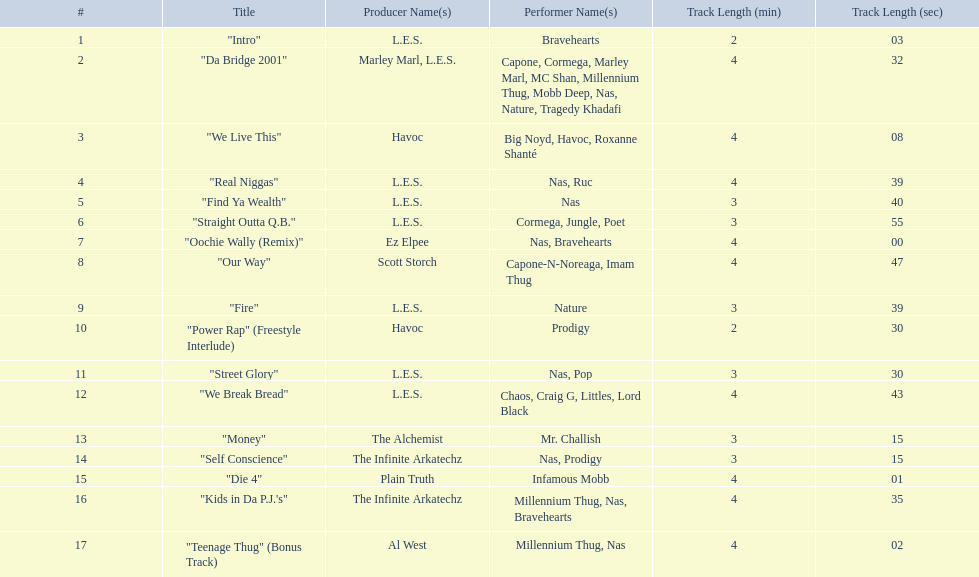What is the name of the last song on the album? "Teenage Thug" (Bonus Track). Can you give me this table as a dict? {'header': ['#', 'Title', 'Producer Name(s)', 'Performer Name(s)', 'Track Length (min)', 'Track Length (sec)'], 'rows': [['1', '"Intro"', 'L.E.S.', 'Bravehearts', '2', '03'], ['2', '"Da Bridge 2001"', 'Marley Marl, L.E.S.', 'Capone, Cormega, Marley Marl, MC Shan, Millennium Thug, Mobb Deep, Nas, Nature, Tragedy Khadafi', '4', '32'], ['3', '"We Live This"', 'Havoc', 'Big Noyd, Havoc, Roxanne Shanté', '4', '08'], ['4', '"Real Niggas"', 'L.E.S.', 'Nas, Ruc', '4', '39'], ['5', '"Find Ya Wealth"', 'L.E.S.', 'Nas', '3', '40'], ['6', '"Straight Outta Q.B."', 'L.E.S.', 'Cormega, Jungle, Poet', '3', '55'], ['7', '"Oochie Wally (Remix)"', 'Ez Elpee', 'Nas, Bravehearts', '4', '00'], ['8', '"Our Way"', 'Scott Storch', 'Capone-N-Noreaga, Imam Thug', '4', '47'], ['9', '"Fire"', 'L.E.S.', 'Nature', '3', '39'], ['10', '"Power Rap" (Freestyle Interlude)', 'Havoc', 'Prodigy', '2', '30'], ['11', '"Street Glory"', 'L.E.S.', 'Nas, Pop', '3', '30'], ['12', '"We Break Bread"', 'L.E.S.', 'Chaos, Craig G, Littles, Lord Black', '4', '43'], ['13', '"Money"', 'The Alchemist', 'Mr. Challish', '3', '15'], ['14', '"Self Conscience"', 'The Infinite Arkatechz', 'Nas, Prodigy', '3', '15'], ['15', '"Die 4"', 'Plain Truth', 'Infamous Mobb', '4', '01'], ['16', '"Kids in Da P.J.\'s"', 'The Infinite Arkatechz', 'Millennium Thug, Nas, Bravehearts', '4', '35'], ['17', '"Teenage Thug" (Bonus Track)', 'Al West', 'Millennium Thug, Nas', '4', '02']]} 